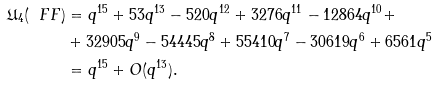<formula> <loc_0><loc_0><loc_500><loc_500>\mathfrak { U } _ { 4 } ( \ F F ) & = q ^ { 1 5 } + 5 3 q ^ { 1 3 } - 5 2 0 q ^ { 1 2 } + 3 2 7 6 q ^ { 1 1 } - 1 2 8 6 4 q ^ { 1 0 } + \\ & + 3 2 9 0 5 q ^ { 9 } - 5 4 4 4 5 q ^ { 8 } + 5 5 4 1 0 q ^ { 7 } - 3 0 6 1 9 q ^ { 6 } + 6 5 6 1 q ^ { 5 } \\ & = q ^ { 1 5 } + O ( q ^ { 1 3 } ) .</formula> 